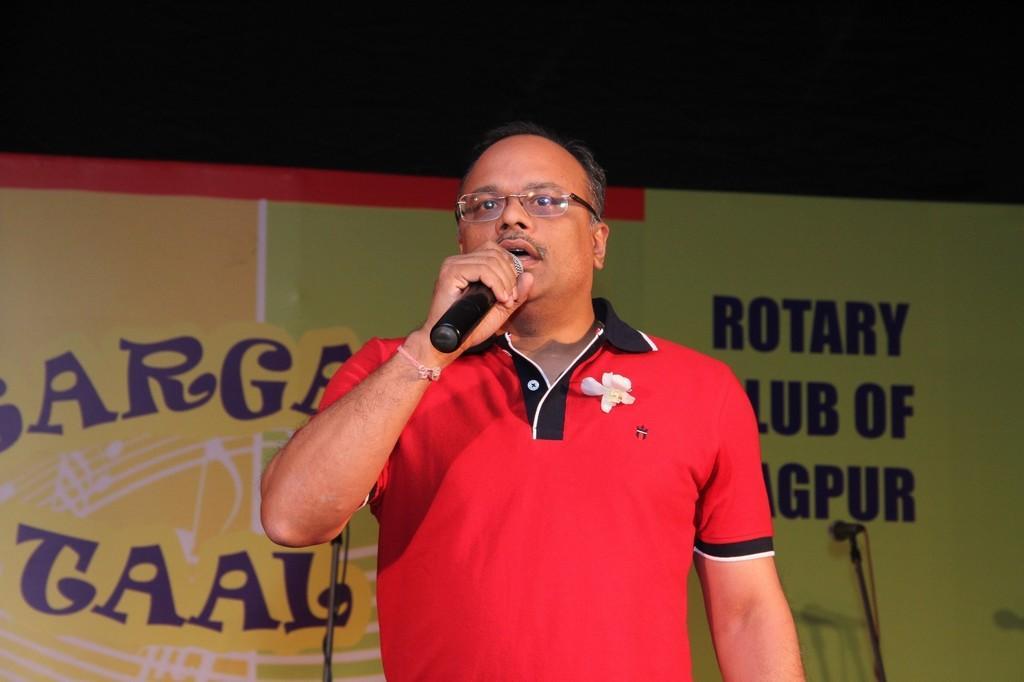Please provide a concise description of this image. In this picture I can see there is a man standing and he is wearing a red t-shirt and holding a microphone and speaking. In the backdrop I can see there is a man standing and there is a banner and there is something written on it. 